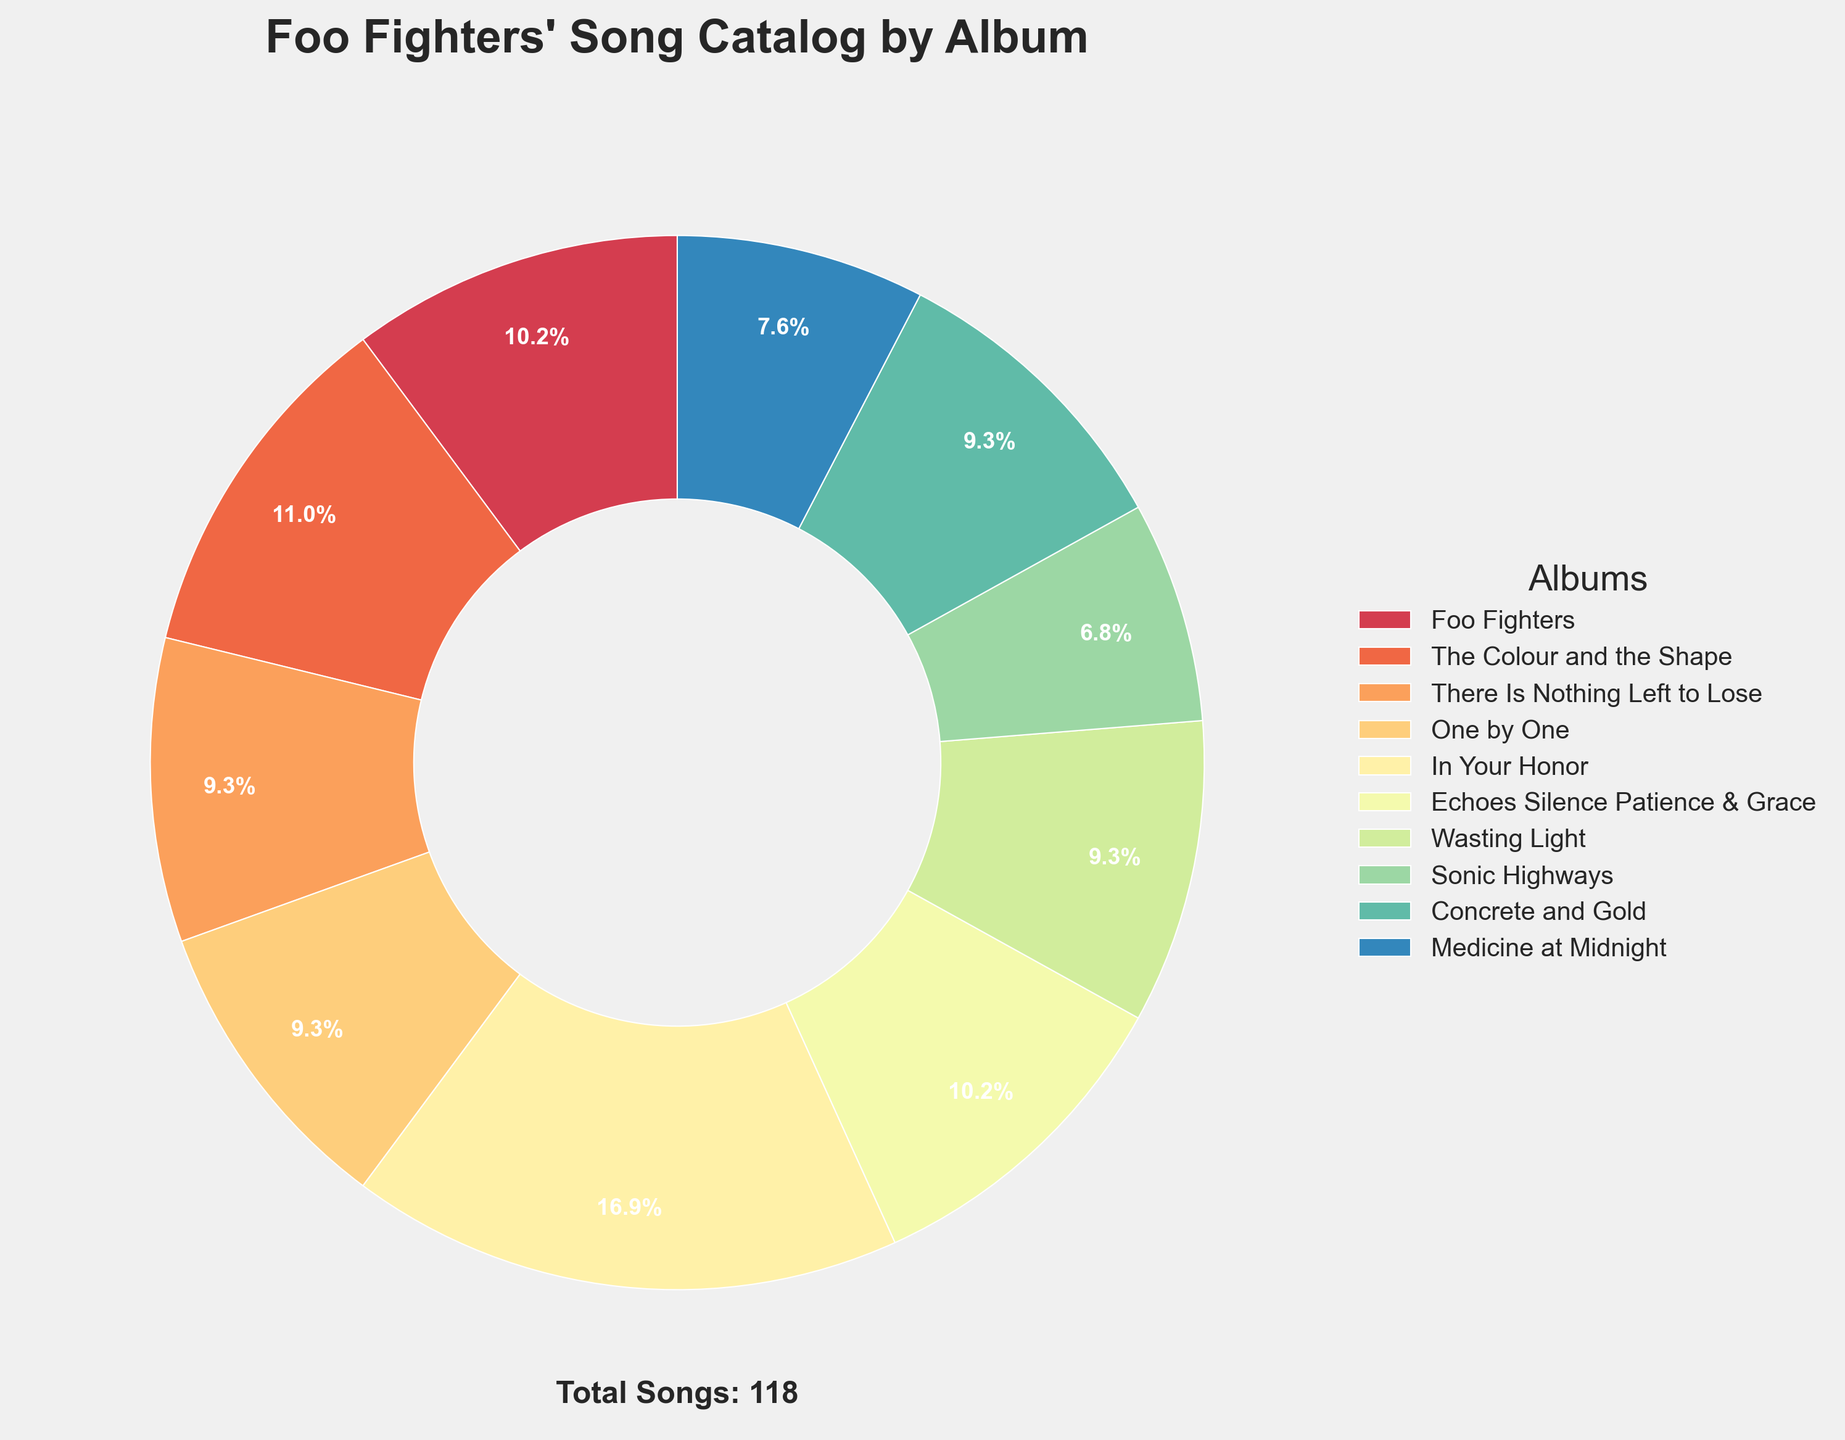What percentage of Foo Fighters' total songs is from the album "In Your Honor"? Look at the pie chart and find the wedge labeled "In Your Honor". It shows "20%", which means 20% of Foo Fighters' total songs are from this album.
Answer: 20% How many songs are there in total across all Foo Fighters' albums? The text below the pie chart states the total number of songs. It reads "Total Songs: 118", indicating the sum of all songs.
Answer: 118 How does the number of songs in "Sonic Highways" compare to "Concrete and Gold"? Find the wedges for "Sonic Highways" and "Concrete and Gold" in the pie chart. "Sonic Highways" has 8 songs, and "Concrete and Gold" has 11 songs. Thus, "Concrete and Gold" has 3 more songs than "Sonic Highways".
Answer: "Concrete and Gold" has 3 more songs What is the combined percentage of songs from "Foo Fighters" and "The Colour and the Shape"? Find the wedges and percentages for both "Foo Fighters" and "The Colour and the Shape". "Foo Fighters" shows 10.2%, and "The Colour and the Shape" shows 11%. Combine these percentages: 10.2% + 11% = 21.2%.
Answer: 21.2% Which album contains the fewest songs, and what is its percentage? Look for the smallest wedge on the pie chart. "Sonic Highways" has 8 songs, which is the fewest. The corresponding percentage is 6.8%.
Answer: "Sonic Highways", 6.8% Is the number of songs in "Medicine at Midnight" more or less than the number in "There Is Nothing Left to Lose"? Check the wedges for "Medicine at Midnight" and "There Is Nothing Left to Lose". "Medicine at Midnight" has 9 songs, while "There Is Nothing Left to Lose" has 11. Thus, "Medicine at Midnight" has fewer songs.
Answer: Less What is the difference in the number of songs between "Wasting Light" and "Echoes Silence Patience & Grace"? Refer to the pie chart wedges to find the number of songs for "Wasting Light" (11) and "Echoes Silence Patience & Grace" (12). The difference is 1 song (12 - 11).
Answer: 1 How many albums have exactly 11 songs? Review the labels around the pie chart and count the albums with exactly 11 songs: "There Is Nothing Left to Lose", "One by One", "Wasting Light", and "Concrete and Gold". This sums to 4 albums.
Answer: 4 Which album has the second highest percentage of Foo Fighters' total song catalog? Find the percentages in the pie chart. The album "In Your Honor" has the highest percentage at 17%, and the album "The Colour and the Shape" has the second highest at 11%.
Answer: "The Colour and the Shape" 